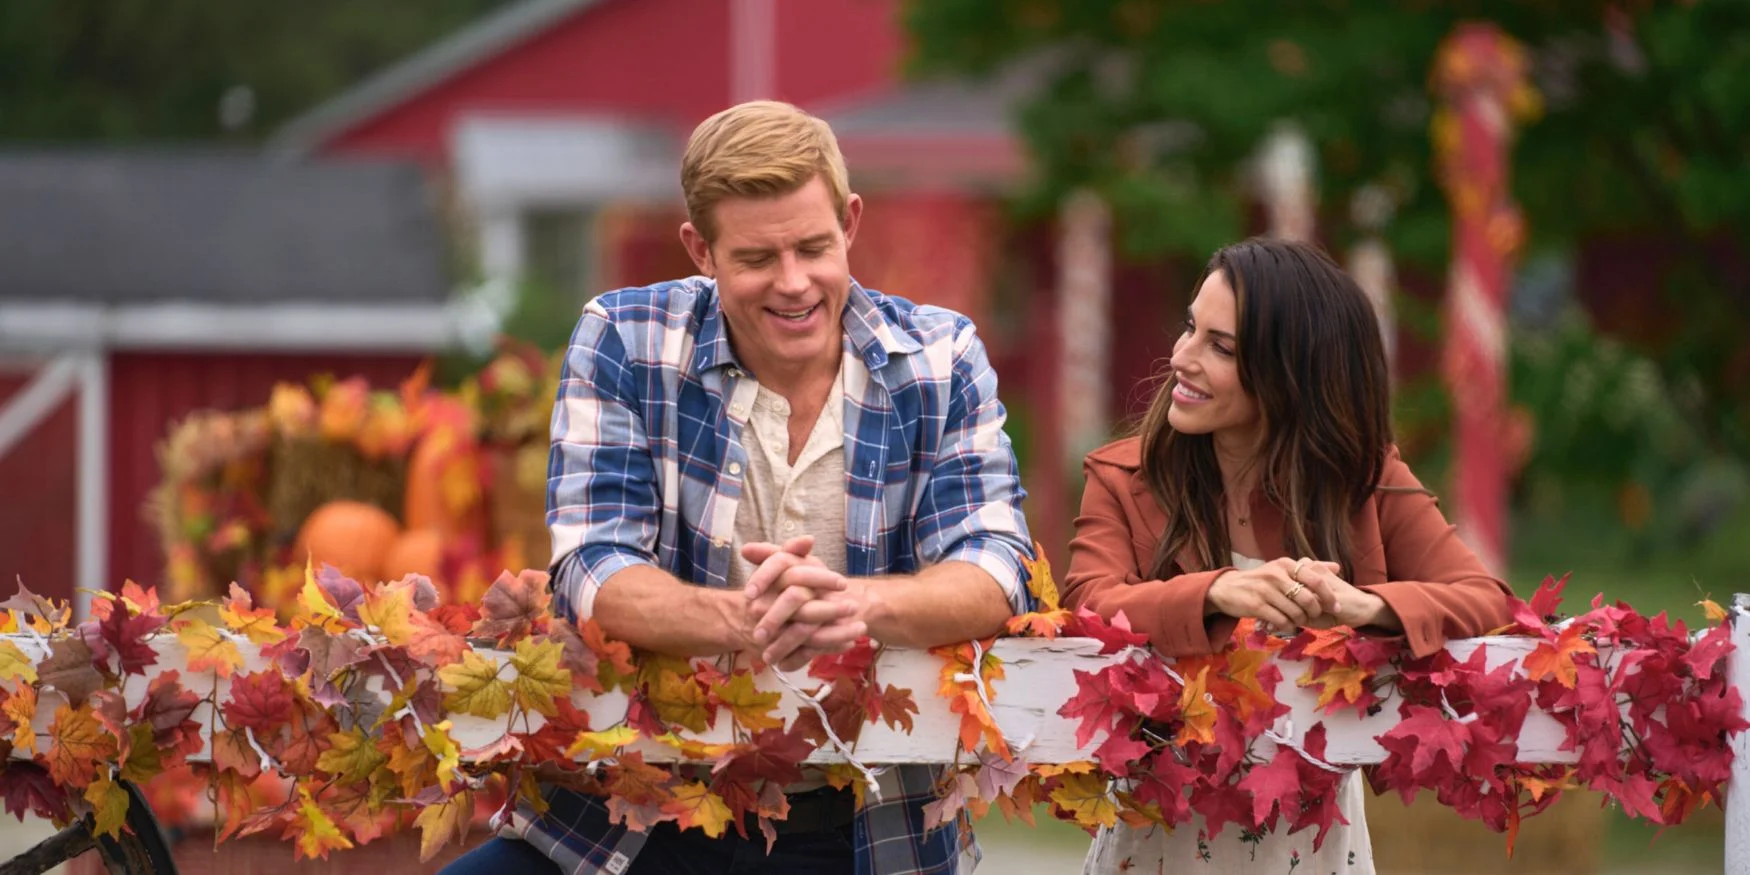Describe the emotions conveyed by the individuals in the image. The individuals in the image convey a sense of joy and camaraderie. Their relaxed postures and warm smiles suggest a friendly and engaging conversation. The man leans casually against a fence, appearing content and at ease. The woman mirrors his relaxed stance, her demeanor radiating warmth and friendliness. The overall emotional tone is one of casual enjoyment and connection, fitting perfectly with the atmospheric backdrop. 